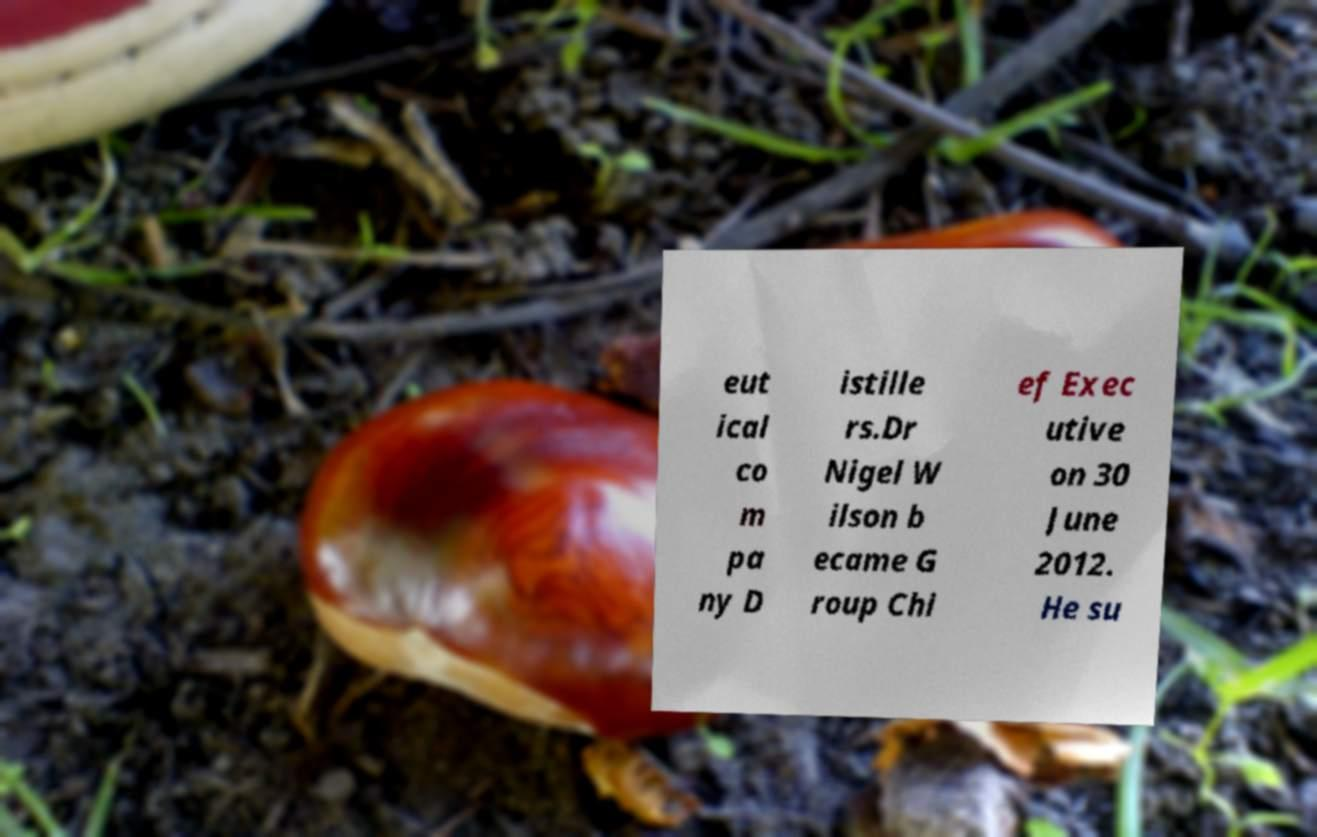What messages or text are displayed in this image? I need them in a readable, typed format. eut ical co m pa ny D istille rs.Dr Nigel W ilson b ecame G roup Chi ef Exec utive on 30 June 2012. He su 